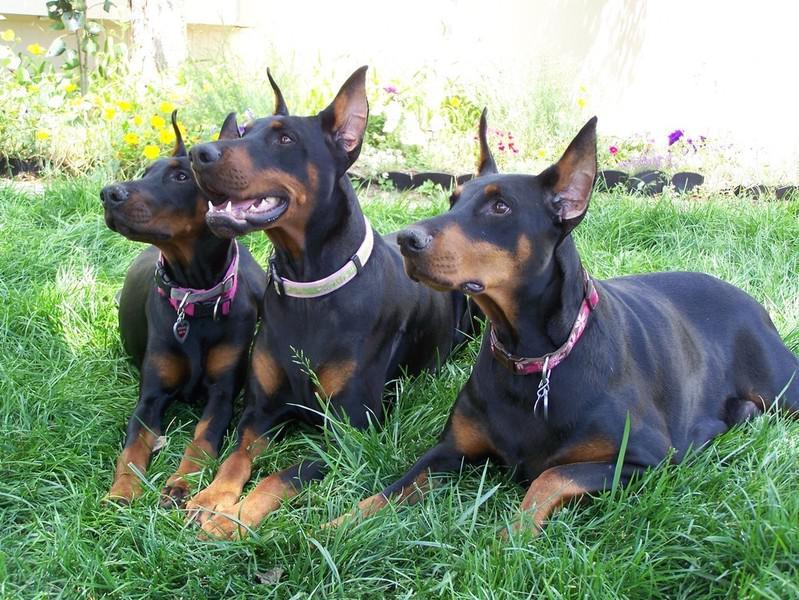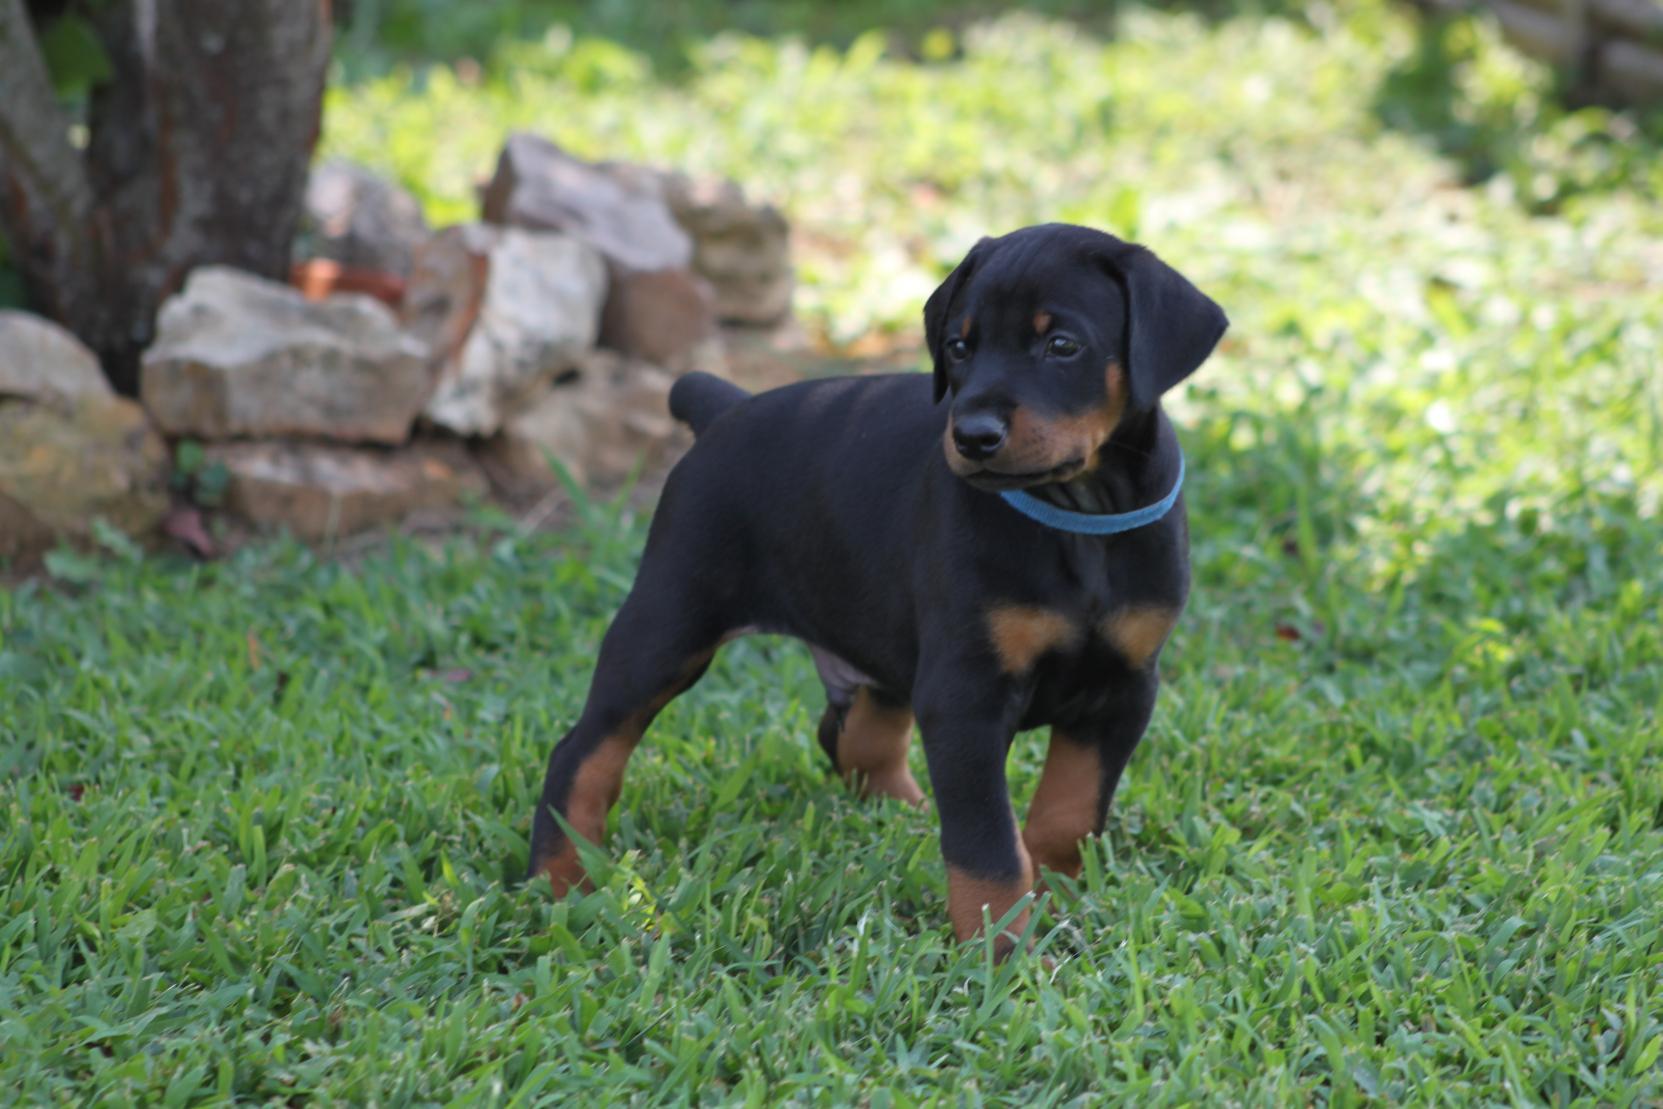The first image is the image on the left, the second image is the image on the right. Assess this claim about the two images: "There are at least three dogs in total.". Correct or not? Answer yes or no. Yes. The first image is the image on the left, the second image is the image on the right. Assess this claim about the two images: "The combined images contain exactly two reclining dobermans with upright ears and faces angled forward so both eyes are visible.". Correct or not? Answer yes or no. No. 